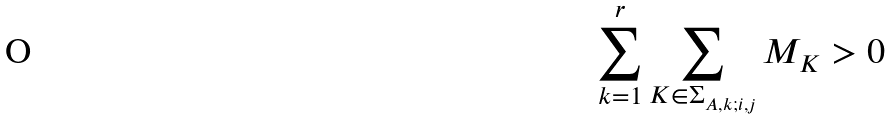Convert formula to latex. <formula><loc_0><loc_0><loc_500><loc_500>\sum _ { k = 1 } ^ { r } \sum _ { K \in \Sigma _ { A , k ; i , j } } M _ { K } > { 0 }</formula> 